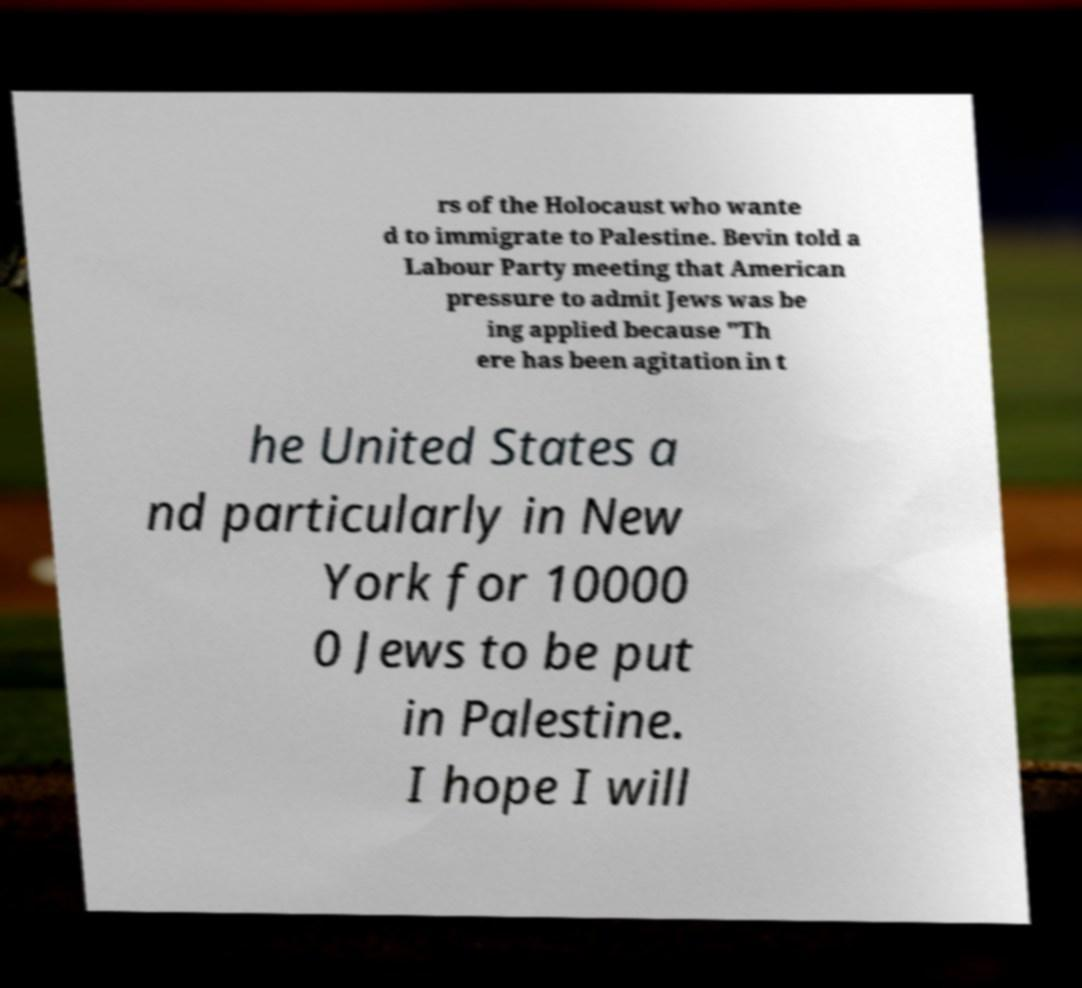Could you extract and type out the text from this image? rs of the Holocaust who wante d to immigrate to Palestine. Bevin told a Labour Party meeting that American pressure to admit Jews was be ing applied because "Th ere has been agitation in t he United States a nd particularly in New York for 10000 0 Jews to be put in Palestine. I hope I will 